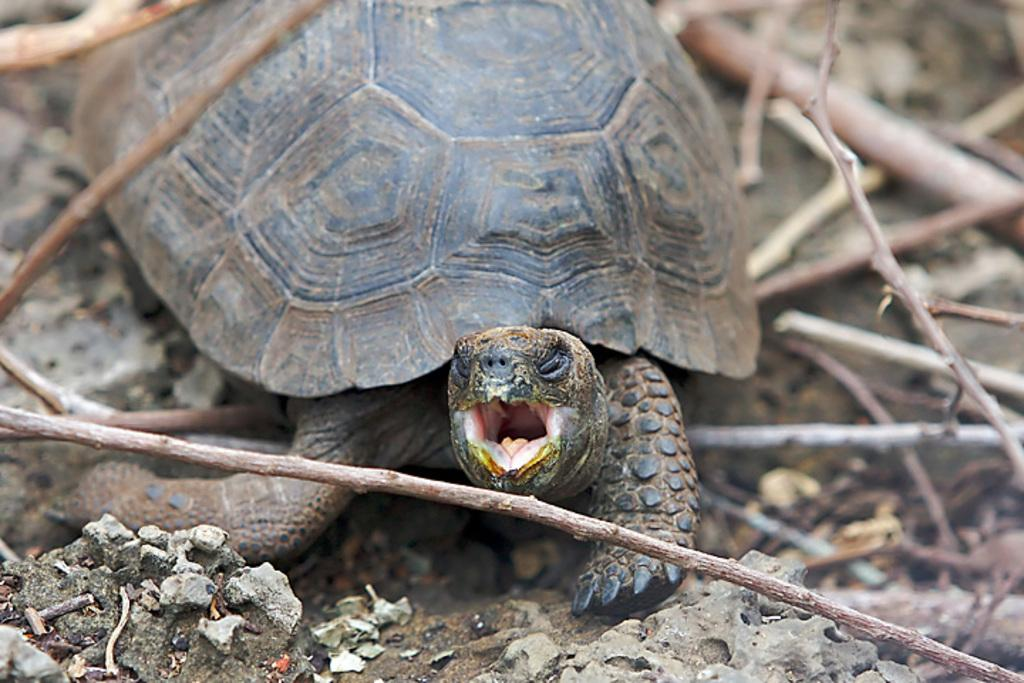What type of animal is in the image? There is a tortoise in the image. What is the surface on which the tortoise is located? There is ground visible in the image. What else can be seen on the ground in the image? There are objects on the ground. What type of material is used to make the sticks in the image? There are wooden sticks in the image. How many ducks are present in the image? There are no ducks present in the image; it features a tortoise and other objects. What type of spiders can be seen weaving webs in the image? There are no spiders present in the image. 